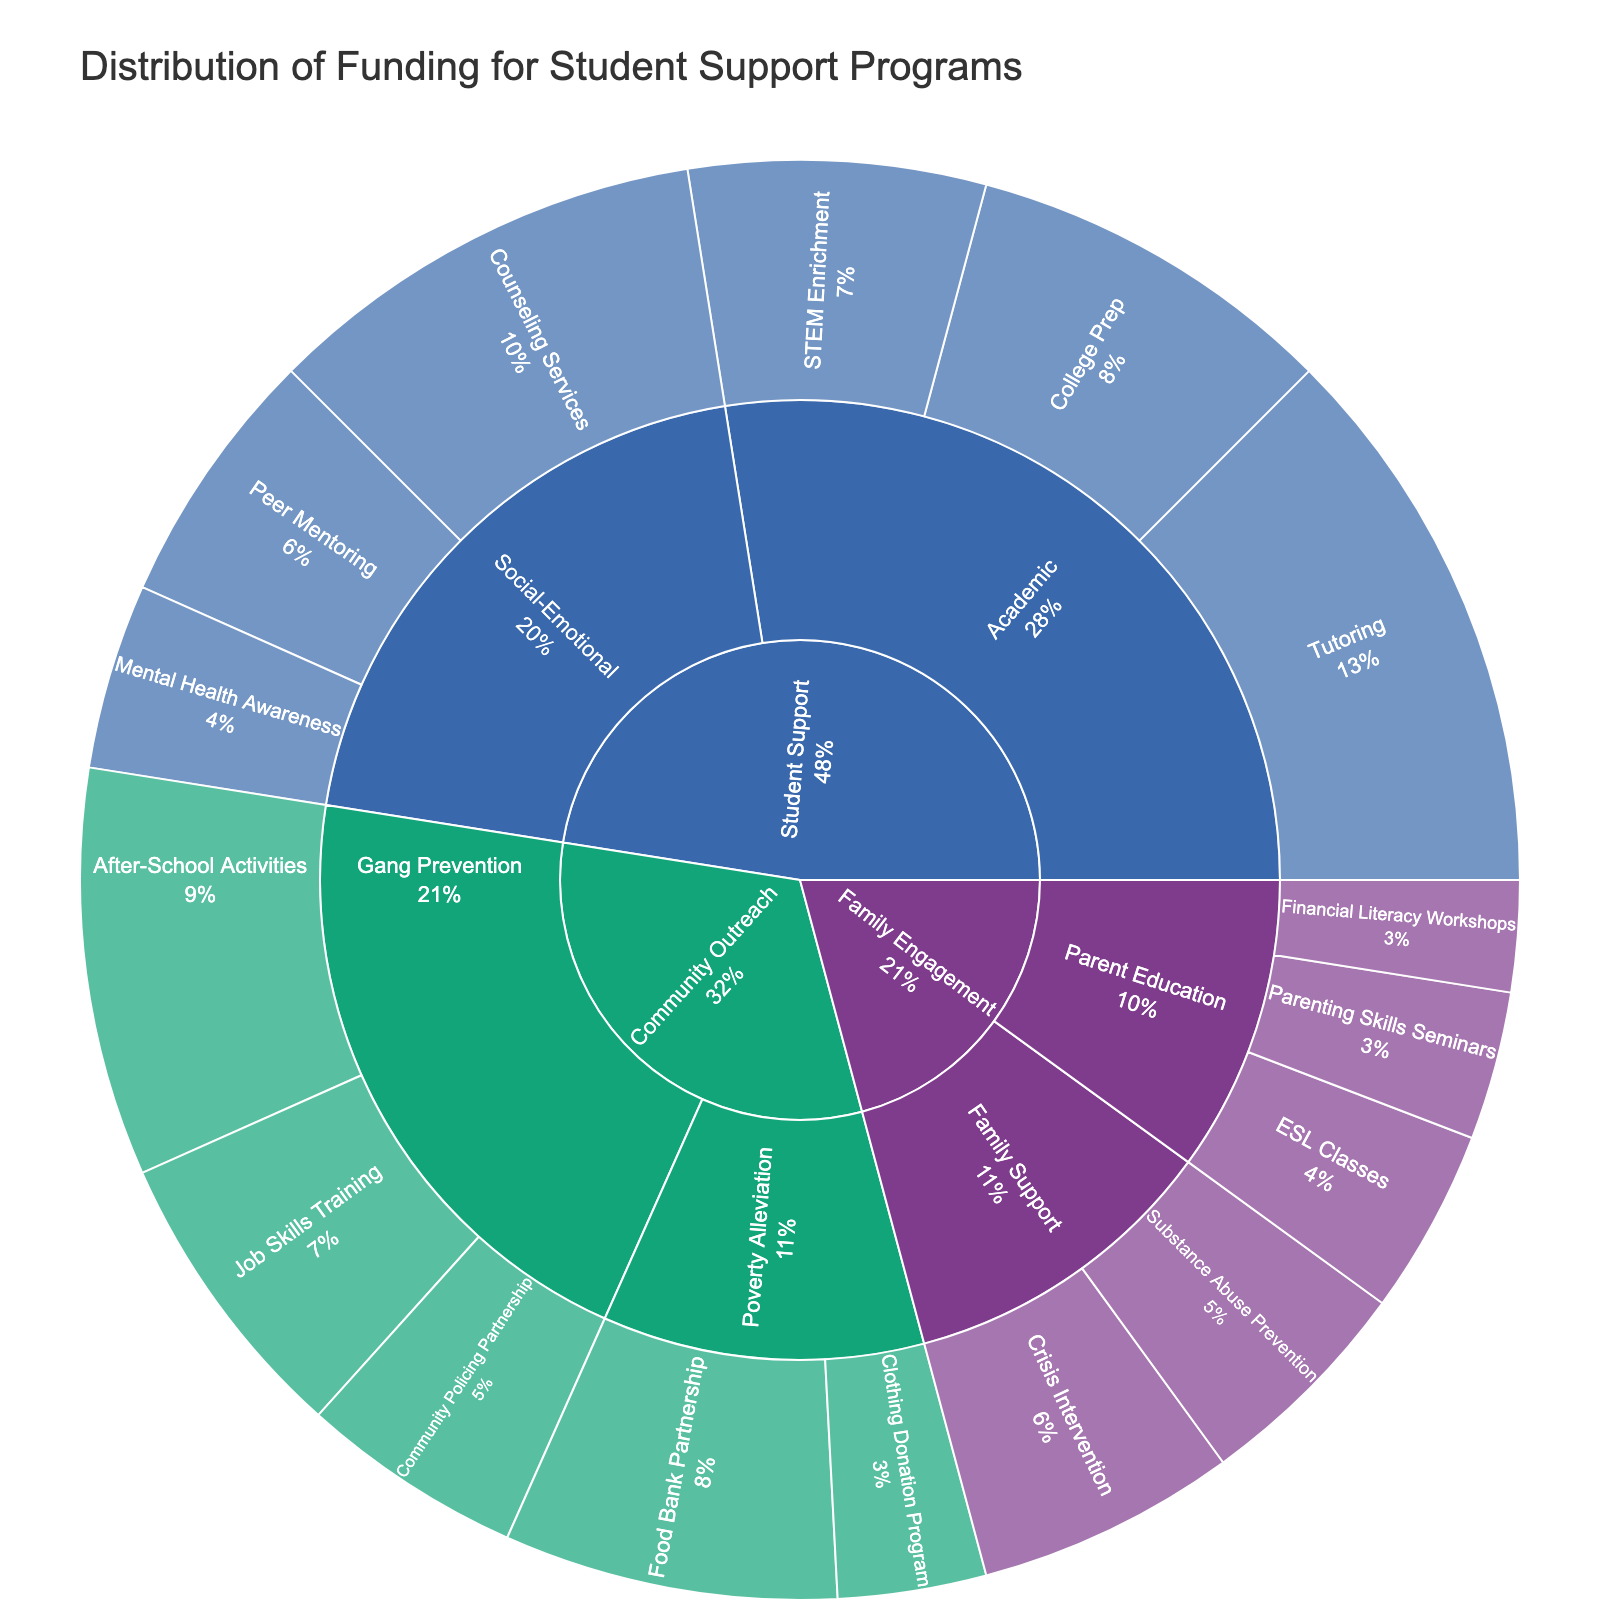What is the total funding for Academic programs? To find the total funding for Academic programs, sum the funding allocations for all subcategories under Academic (Tutoring, College Prep, and STEM Enrichment): $150,000 + $100,000 + $80,000 = $330,000
Answer: $330,000 Which subcategory in Social-Emotional has the highest funding? To identify the subcategory with the highest funding in Social-Emotional, compare the funding for Counseling Services, Peer Mentoring, and Mental Health Awareness. Counseling Services has $120,000 which is higher than Peer Mentoring ($70,000) and Mental Health Awareness ($50,000)
Answer: Counseling Services How much more funding is allocated to After-School Activities compared to Community Policing Partnership? Subtract the funding for Community Policing Partnership from the funding for After-School Activities: $110,000 - $60,000. This gives us $50,000 more for After-School Activities
Answer: $50,000 What is the proportion of total funding allocated to Community Outreach programs compared to the overall funding? Sum the funding for all Community Outreach subcategories (Food Bank Partnership, Clothing Donation Program, After-School Activities, Job Skills Training, and Community Policing Partnership): $90,000 + $40,000 + $110,000 + $80,000 + $60,000 = $380,000. Then, sum the total funding across all programs which is $1,080,000. Finally, calculate the proportion $380,000 / $1,080,000 ≈ 0.35 or 35%
Answer: 35% Which program received the least funding and what is the amount? Review all programs' funding and identify the one with the smallest funding allocation. Financial Literacy Workshops under Parent Education received $30,000, the least amount
Answer: Financial Literacy Workshops, $30,000 How does the funding for Parent Education compare to Family Support within Family Engagement? Sum the funding for subcategories under Parent Education (Financial Literacy Workshops, ESL Classes, and Parenting Skills Seminars): $30,000 + $50,000 + $40,000 = $120,000. Next, sum the funding for Family Support (Crisis Intervention and Substance Abuse Prevention): $70,000 + $60,000 = $130,000. Comparing these totals, Parent Education funds ($120,000) are less than Family Support funds ($130,000)
Answer: Parent Education has $10,000 less than Family Support What percentage of the Social-Emotional funding is allocated to Peer Mentoring? Total funding for Social-Emotional subcategories: Counseling Services ($120,000), Peer Mentoring ($70,000), and Mental Health Awareness ($50,000) which sums up to $240,000. The percentage is then calculated as ($70,000 / $240,000) * 100 ≈ 29.2%
Answer: 29.2% How much funding is allocated to all support programs under Family Engagement? Sum the funding for all Family Engagement subcategories: Financial Literacy Workshops ($30,000), ESL Classes ($50,000), Parenting Skills Seminars ($40,000), Crisis Intervention ($70,000), and Substance Abuse Prevention ($60,000). This gives $30,000 + $50,000 + $40,000 + $70,000 + $60,000 = $250,000
Answer: $250,000 